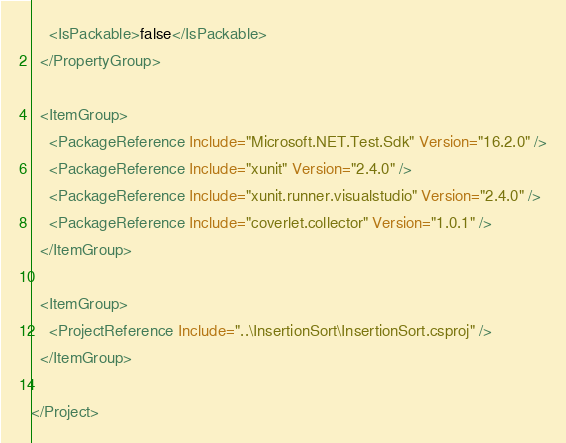<code> <loc_0><loc_0><loc_500><loc_500><_XML_>    <IsPackable>false</IsPackable>
  </PropertyGroup>

  <ItemGroup>
    <PackageReference Include="Microsoft.NET.Test.Sdk" Version="16.2.0" />
    <PackageReference Include="xunit" Version="2.4.0" />
    <PackageReference Include="xunit.runner.visualstudio" Version="2.4.0" />
    <PackageReference Include="coverlet.collector" Version="1.0.1" />
  </ItemGroup>

  <ItemGroup>
    <ProjectReference Include="..\InsertionSort\InsertionSort.csproj" />
  </ItemGroup>

</Project>
</code> 